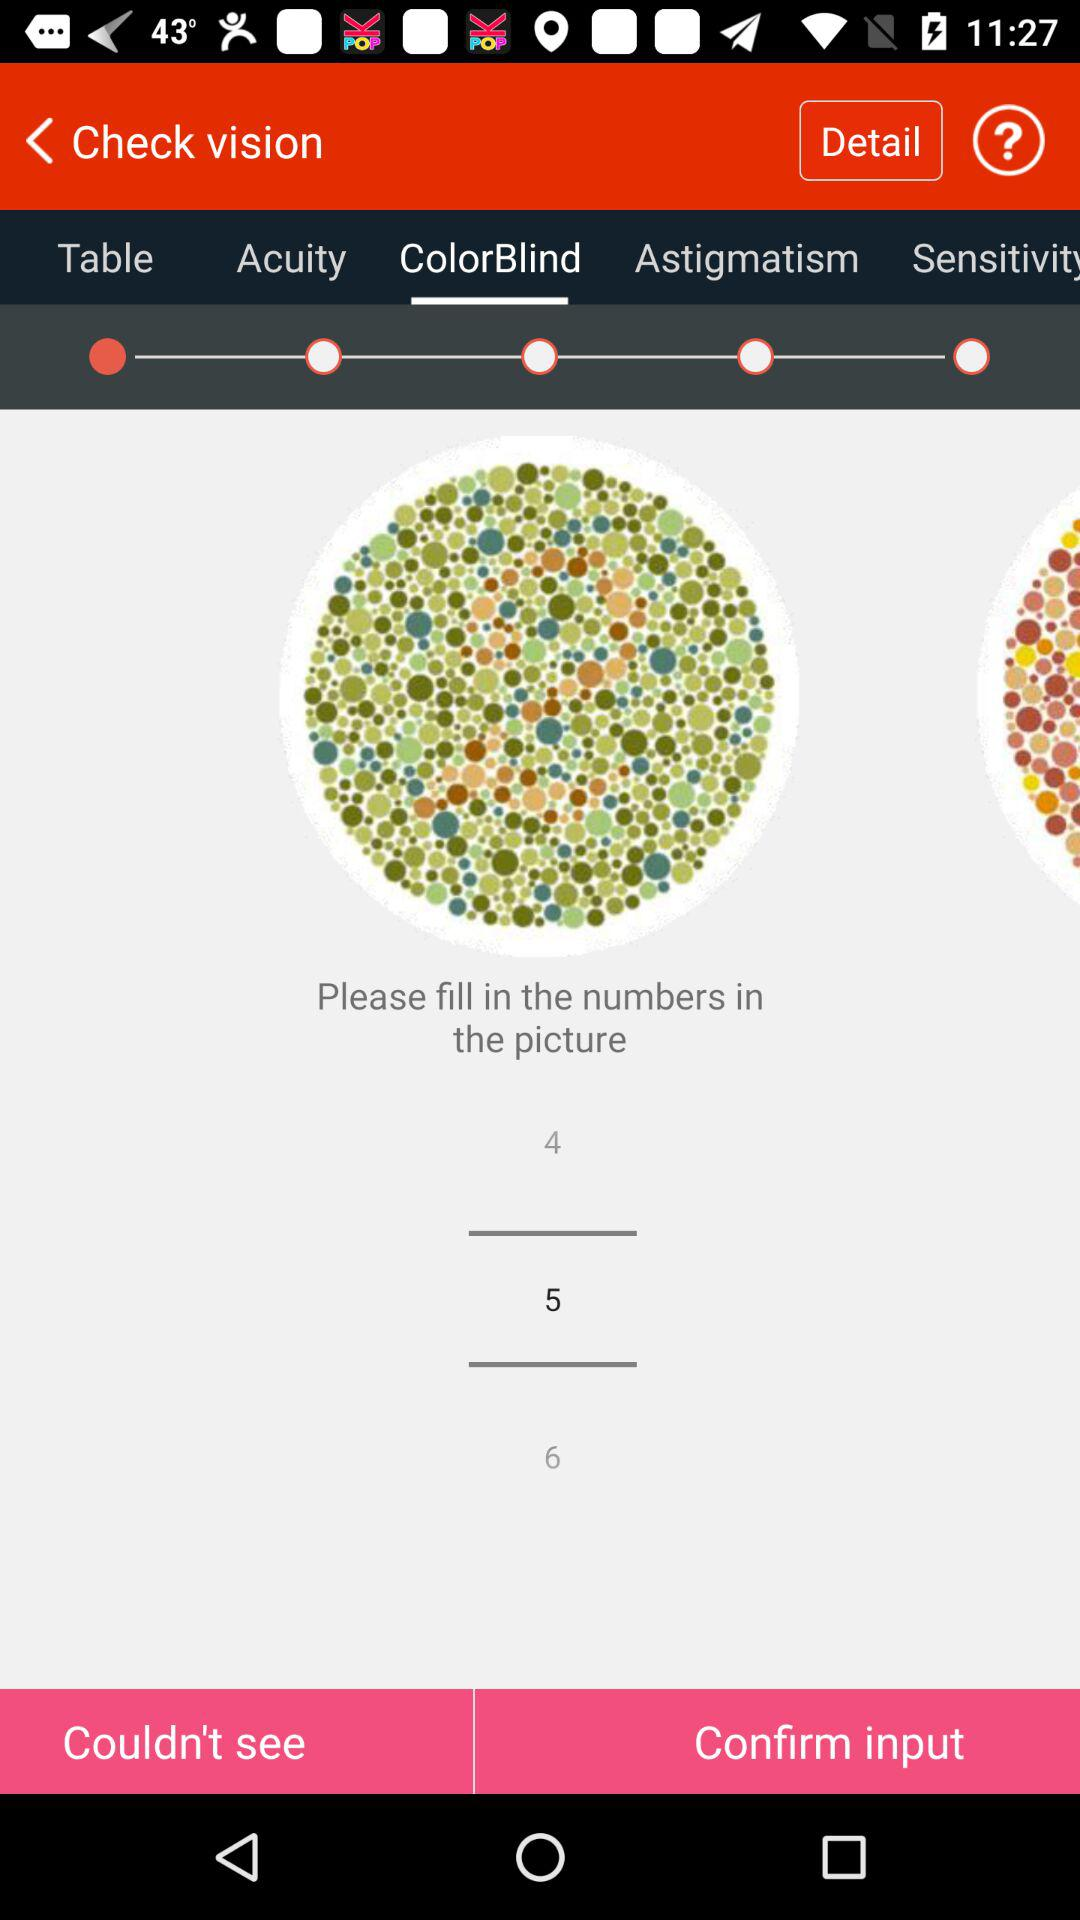Which number is selected? The selected number is 5. 